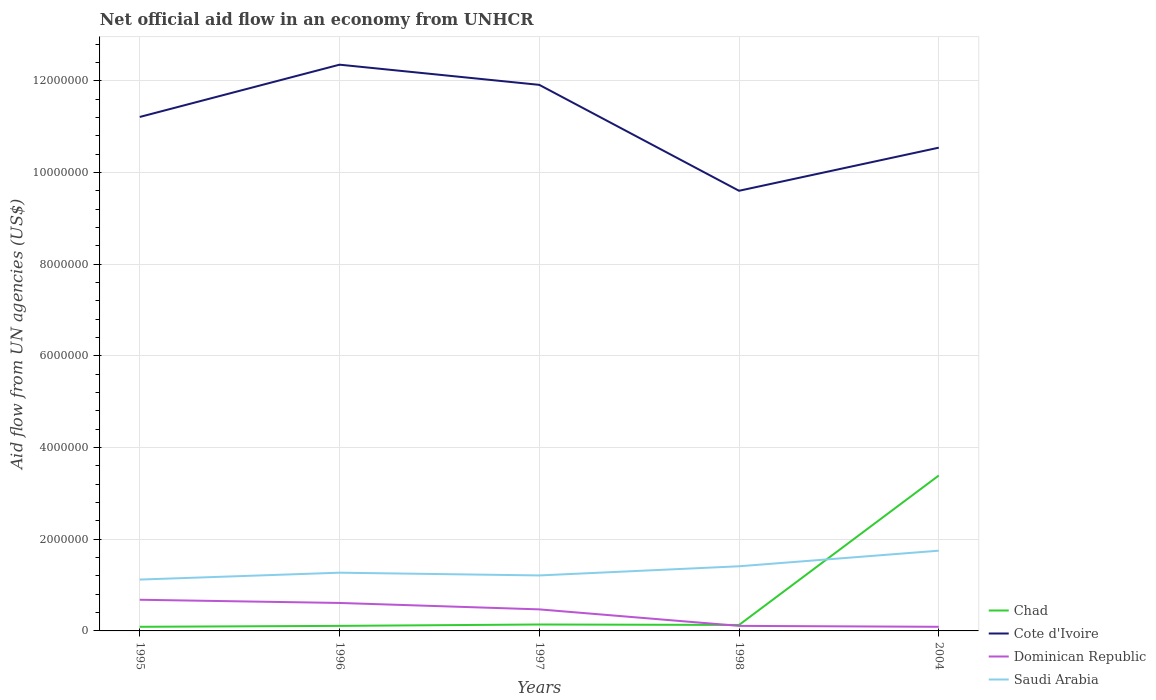Across all years, what is the maximum net official aid flow in Saudi Arabia?
Your answer should be compact. 1.12e+06. In which year was the net official aid flow in Saudi Arabia maximum?
Give a very brief answer. 1995. What is the total net official aid flow in Cote d'Ivoire in the graph?
Offer a terse response. 2.31e+06. What is the difference between the highest and the second highest net official aid flow in Dominican Republic?
Make the answer very short. 5.90e+05. What is the difference between the highest and the lowest net official aid flow in Dominican Republic?
Your response must be concise. 3. How many lines are there?
Make the answer very short. 4. How many years are there in the graph?
Your answer should be very brief. 5. Does the graph contain any zero values?
Your answer should be compact. No. Does the graph contain grids?
Keep it short and to the point. Yes. How many legend labels are there?
Your answer should be very brief. 4. How are the legend labels stacked?
Provide a short and direct response. Vertical. What is the title of the graph?
Provide a succinct answer. Net official aid flow in an economy from UNHCR. What is the label or title of the Y-axis?
Your response must be concise. Aid flow from UN agencies (US$). What is the Aid flow from UN agencies (US$) in Chad in 1995?
Your answer should be very brief. 9.00e+04. What is the Aid flow from UN agencies (US$) of Cote d'Ivoire in 1995?
Offer a terse response. 1.12e+07. What is the Aid flow from UN agencies (US$) in Dominican Republic in 1995?
Ensure brevity in your answer.  6.80e+05. What is the Aid flow from UN agencies (US$) of Saudi Arabia in 1995?
Keep it short and to the point. 1.12e+06. What is the Aid flow from UN agencies (US$) in Chad in 1996?
Your response must be concise. 1.10e+05. What is the Aid flow from UN agencies (US$) in Cote d'Ivoire in 1996?
Ensure brevity in your answer.  1.24e+07. What is the Aid flow from UN agencies (US$) in Saudi Arabia in 1996?
Provide a succinct answer. 1.27e+06. What is the Aid flow from UN agencies (US$) in Cote d'Ivoire in 1997?
Your answer should be very brief. 1.19e+07. What is the Aid flow from UN agencies (US$) in Saudi Arabia in 1997?
Make the answer very short. 1.21e+06. What is the Aid flow from UN agencies (US$) of Chad in 1998?
Your answer should be very brief. 1.30e+05. What is the Aid flow from UN agencies (US$) of Cote d'Ivoire in 1998?
Your response must be concise. 9.60e+06. What is the Aid flow from UN agencies (US$) of Dominican Republic in 1998?
Your answer should be very brief. 1.10e+05. What is the Aid flow from UN agencies (US$) in Saudi Arabia in 1998?
Your answer should be compact. 1.41e+06. What is the Aid flow from UN agencies (US$) of Chad in 2004?
Your response must be concise. 3.39e+06. What is the Aid flow from UN agencies (US$) in Cote d'Ivoire in 2004?
Your response must be concise. 1.05e+07. What is the Aid flow from UN agencies (US$) in Dominican Republic in 2004?
Ensure brevity in your answer.  9.00e+04. What is the Aid flow from UN agencies (US$) of Saudi Arabia in 2004?
Offer a very short reply. 1.75e+06. Across all years, what is the maximum Aid flow from UN agencies (US$) in Chad?
Provide a short and direct response. 3.39e+06. Across all years, what is the maximum Aid flow from UN agencies (US$) of Cote d'Ivoire?
Provide a succinct answer. 1.24e+07. Across all years, what is the maximum Aid flow from UN agencies (US$) of Dominican Republic?
Provide a short and direct response. 6.80e+05. Across all years, what is the maximum Aid flow from UN agencies (US$) of Saudi Arabia?
Provide a short and direct response. 1.75e+06. Across all years, what is the minimum Aid flow from UN agencies (US$) of Chad?
Your answer should be very brief. 9.00e+04. Across all years, what is the minimum Aid flow from UN agencies (US$) of Cote d'Ivoire?
Your response must be concise. 9.60e+06. Across all years, what is the minimum Aid flow from UN agencies (US$) in Saudi Arabia?
Provide a short and direct response. 1.12e+06. What is the total Aid flow from UN agencies (US$) in Chad in the graph?
Your response must be concise. 3.86e+06. What is the total Aid flow from UN agencies (US$) in Cote d'Ivoire in the graph?
Give a very brief answer. 5.56e+07. What is the total Aid flow from UN agencies (US$) in Dominican Republic in the graph?
Your answer should be compact. 1.96e+06. What is the total Aid flow from UN agencies (US$) in Saudi Arabia in the graph?
Your answer should be compact. 6.76e+06. What is the difference between the Aid flow from UN agencies (US$) of Chad in 1995 and that in 1996?
Your answer should be compact. -2.00e+04. What is the difference between the Aid flow from UN agencies (US$) in Cote d'Ivoire in 1995 and that in 1996?
Offer a very short reply. -1.14e+06. What is the difference between the Aid flow from UN agencies (US$) in Cote d'Ivoire in 1995 and that in 1997?
Provide a short and direct response. -7.00e+05. What is the difference between the Aid flow from UN agencies (US$) of Dominican Republic in 1995 and that in 1997?
Offer a terse response. 2.10e+05. What is the difference between the Aid flow from UN agencies (US$) in Cote d'Ivoire in 1995 and that in 1998?
Offer a terse response. 1.61e+06. What is the difference between the Aid flow from UN agencies (US$) in Dominican Republic in 1995 and that in 1998?
Provide a succinct answer. 5.70e+05. What is the difference between the Aid flow from UN agencies (US$) in Chad in 1995 and that in 2004?
Your response must be concise. -3.30e+06. What is the difference between the Aid flow from UN agencies (US$) of Cote d'Ivoire in 1995 and that in 2004?
Ensure brevity in your answer.  6.70e+05. What is the difference between the Aid flow from UN agencies (US$) in Dominican Republic in 1995 and that in 2004?
Offer a terse response. 5.90e+05. What is the difference between the Aid flow from UN agencies (US$) of Saudi Arabia in 1995 and that in 2004?
Offer a very short reply. -6.30e+05. What is the difference between the Aid flow from UN agencies (US$) of Chad in 1996 and that in 1997?
Make the answer very short. -3.00e+04. What is the difference between the Aid flow from UN agencies (US$) in Cote d'Ivoire in 1996 and that in 1997?
Ensure brevity in your answer.  4.40e+05. What is the difference between the Aid flow from UN agencies (US$) of Cote d'Ivoire in 1996 and that in 1998?
Provide a succinct answer. 2.75e+06. What is the difference between the Aid flow from UN agencies (US$) in Chad in 1996 and that in 2004?
Give a very brief answer. -3.28e+06. What is the difference between the Aid flow from UN agencies (US$) in Cote d'Ivoire in 1996 and that in 2004?
Your answer should be very brief. 1.81e+06. What is the difference between the Aid flow from UN agencies (US$) in Dominican Republic in 1996 and that in 2004?
Your answer should be very brief. 5.20e+05. What is the difference between the Aid flow from UN agencies (US$) in Saudi Arabia in 1996 and that in 2004?
Ensure brevity in your answer.  -4.80e+05. What is the difference between the Aid flow from UN agencies (US$) in Cote d'Ivoire in 1997 and that in 1998?
Provide a succinct answer. 2.31e+06. What is the difference between the Aid flow from UN agencies (US$) in Dominican Republic in 1997 and that in 1998?
Keep it short and to the point. 3.60e+05. What is the difference between the Aid flow from UN agencies (US$) of Saudi Arabia in 1997 and that in 1998?
Make the answer very short. -2.00e+05. What is the difference between the Aid flow from UN agencies (US$) of Chad in 1997 and that in 2004?
Provide a short and direct response. -3.25e+06. What is the difference between the Aid flow from UN agencies (US$) of Cote d'Ivoire in 1997 and that in 2004?
Your answer should be compact. 1.37e+06. What is the difference between the Aid flow from UN agencies (US$) in Dominican Republic in 1997 and that in 2004?
Your answer should be compact. 3.80e+05. What is the difference between the Aid flow from UN agencies (US$) in Saudi Arabia in 1997 and that in 2004?
Give a very brief answer. -5.40e+05. What is the difference between the Aid flow from UN agencies (US$) in Chad in 1998 and that in 2004?
Make the answer very short. -3.26e+06. What is the difference between the Aid flow from UN agencies (US$) in Cote d'Ivoire in 1998 and that in 2004?
Offer a very short reply. -9.40e+05. What is the difference between the Aid flow from UN agencies (US$) of Dominican Republic in 1998 and that in 2004?
Ensure brevity in your answer.  2.00e+04. What is the difference between the Aid flow from UN agencies (US$) of Chad in 1995 and the Aid flow from UN agencies (US$) of Cote d'Ivoire in 1996?
Keep it short and to the point. -1.23e+07. What is the difference between the Aid flow from UN agencies (US$) in Chad in 1995 and the Aid flow from UN agencies (US$) in Dominican Republic in 1996?
Ensure brevity in your answer.  -5.20e+05. What is the difference between the Aid flow from UN agencies (US$) of Chad in 1995 and the Aid flow from UN agencies (US$) of Saudi Arabia in 1996?
Keep it short and to the point. -1.18e+06. What is the difference between the Aid flow from UN agencies (US$) in Cote d'Ivoire in 1995 and the Aid flow from UN agencies (US$) in Dominican Republic in 1996?
Offer a terse response. 1.06e+07. What is the difference between the Aid flow from UN agencies (US$) in Cote d'Ivoire in 1995 and the Aid flow from UN agencies (US$) in Saudi Arabia in 1996?
Offer a terse response. 9.94e+06. What is the difference between the Aid flow from UN agencies (US$) of Dominican Republic in 1995 and the Aid flow from UN agencies (US$) of Saudi Arabia in 1996?
Your response must be concise. -5.90e+05. What is the difference between the Aid flow from UN agencies (US$) of Chad in 1995 and the Aid flow from UN agencies (US$) of Cote d'Ivoire in 1997?
Make the answer very short. -1.18e+07. What is the difference between the Aid flow from UN agencies (US$) of Chad in 1995 and the Aid flow from UN agencies (US$) of Dominican Republic in 1997?
Offer a very short reply. -3.80e+05. What is the difference between the Aid flow from UN agencies (US$) of Chad in 1995 and the Aid flow from UN agencies (US$) of Saudi Arabia in 1997?
Give a very brief answer. -1.12e+06. What is the difference between the Aid flow from UN agencies (US$) of Cote d'Ivoire in 1995 and the Aid flow from UN agencies (US$) of Dominican Republic in 1997?
Your answer should be very brief. 1.07e+07. What is the difference between the Aid flow from UN agencies (US$) of Cote d'Ivoire in 1995 and the Aid flow from UN agencies (US$) of Saudi Arabia in 1997?
Provide a succinct answer. 1.00e+07. What is the difference between the Aid flow from UN agencies (US$) in Dominican Republic in 1995 and the Aid flow from UN agencies (US$) in Saudi Arabia in 1997?
Your response must be concise. -5.30e+05. What is the difference between the Aid flow from UN agencies (US$) of Chad in 1995 and the Aid flow from UN agencies (US$) of Cote d'Ivoire in 1998?
Your response must be concise. -9.51e+06. What is the difference between the Aid flow from UN agencies (US$) in Chad in 1995 and the Aid flow from UN agencies (US$) in Dominican Republic in 1998?
Your answer should be compact. -2.00e+04. What is the difference between the Aid flow from UN agencies (US$) of Chad in 1995 and the Aid flow from UN agencies (US$) of Saudi Arabia in 1998?
Your response must be concise. -1.32e+06. What is the difference between the Aid flow from UN agencies (US$) of Cote d'Ivoire in 1995 and the Aid flow from UN agencies (US$) of Dominican Republic in 1998?
Offer a terse response. 1.11e+07. What is the difference between the Aid flow from UN agencies (US$) in Cote d'Ivoire in 1995 and the Aid flow from UN agencies (US$) in Saudi Arabia in 1998?
Offer a terse response. 9.80e+06. What is the difference between the Aid flow from UN agencies (US$) in Dominican Republic in 1995 and the Aid flow from UN agencies (US$) in Saudi Arabia in 1998?
Keep it short and to the point. -7.30e+05. What is the difference between the Aid flow from UN agencies (US$) of Chad in 1995 and the Aid flow from UN agencies (US$) of Cote d'Ivoire in 2004?
Your response must be concise. -1.04e+07. What is the difference between the Aid flow from UN agencies (US$) in Chad in 1995 and the Aid flow from UN agencies (US$) in Dominican Republic in 2004?
Offer a very short reply. 0. What is the difference between the Aid flow from UN agencies (US$) of Chad in 1995 and the Aid flow from UN agencies (US$) of Saudi Arabia in 2004?
Your answer should be compact. -1.66e+06. What is the difference between the Aid flow from UN agencies (US$) of Cote d'Ivoire in 1995 and the Aid flow from UN agencies (US$) of Dominican Republic in 2004?
Your answer should be very brief. 1.11e+07. What is the difference between the Aid flow from UN agencies (US$) in Cote d'Ivoire in 1995 and the Aid flow from UN agencies (US$) in Saudi Arabia in 2004?
Offer a terse response. 9.46e+06. What is the difference between the Aid flow from UN agencies (US$) in Dominican Republic in 1995 and the Aid flow from UN agencies (US$) in Saudi Arabia in 2004?
Give a very brief answer. -1.07e+06. What is the difference between the Aid flow from UN agencies (US$) of Chad in 1996 and the Aid flow from UN agencies (US$) of Cote d'Ivoire in 1997?
Keep it short and to the point. -1.18e+07. What is the difference between the Aid flow from UN agencies (US$) of Chad in 1996 and the Aid flow from UN agencies (US$) of Dominican Republic in 1997?
Keep it short and to the point. -3.60e+05. What is the difference between the Aid flow from UN agencies (US$) in Chad in 1996 and the Aid flow from UN agencies (US$) in Saudi Arabia in 1997?
Make the answer very short. -1.10e+06. What is the difference between the Aid flow from UN agencies (US$) in Cote d'Ivoire in 1996 and the Aid flow from UN agencies (US$) in Dominican Republic in 1997?
Your answer should be compact. 1.19e+07. What is the difference between the Aid flow from UN agencies (US$) in Cote d'Ivoire in 1996 and the Aid flow from UN agencies (US$) in Saudi Arabia in 1997?
Provide a short and direct response. 1.11e+07. What is the difference between the Aid flow from UN agencies (US$) in Dominican Republic in 1996 and the Aid flow from UN agencies (US$) in Saudi Arabia in 1997?
Your response must be concise. -6.00e+05. What is the difference between the Aid flow from UN agencies (US$) in Chad in 1996 and the Aid flow from UN agencies (US$) in Cote d'Ivoire in 1998?
Give a very brief answer. -9.49e+06. What is the difference between the Aid flow from UN agencies (US$) of Chad in 1996 and the Aid flow from UN agencies (US$) of Saudi Arabia in 1998?
Your answer should be very brief. -1.30e+06. What is the difference between the Aid flow from UN agencies (US$) in Cote d'Ivoire in 1996 and the Aid flow from UN agencies (US$) in Dominican Republic in 1998?
Offer a terse response. 1.22e+07. What is the difference between the Aid flow from UN agencies (US$) of Cote d'Ivoire in 1996 and the Aid flow from UN agencies (US$) of Saudi Arabia in 1998?
Provide a succinct answer. 1.09e+07. What is the difference between the Aid flow from UN agencies (US$) of Dominican Republic in 1996 and the Aid flow from UN agencies (US$) of Saudi Arabia in 1998?
Your response must be concise. -8.00e+05. What is the difference between the Aid flow from UN agencies (US$) of Chad in 1996 and the Aid flow from UN agencies (US$) of Cote d'Ivoire in 2004?
Your answer should be very brief. -1.04e+07. What is the difference between the Aid flow from UN agencies (US$) of Chad in 1996 and the Aid flow from UN agencies (US$) of Dominican Republic in 2004?
Keep it short and to the point. 2.00e+04. What is the difference between the Aid flow from UN agencies (US$) of Chad in 1996 and the Aid flow from UN agencies (US$) of Saudi Arabia in 2004?
Give a very brief answer. -1.64e+06. What is the difference between the Aid flow from UN agencies (US$) of Cote d'Ivoire in 1996 and the Aid flow from UN agencies (US$) of Dominican Republic in 2004?
Your answer should be compact. 1.23e+07. What is the difference between the Aid flow from UN agencies (US$) of Cote d'Ivoire in 1996 and the Aid flow from UN agencies (US$) of Saudi Arabia in 2004?
Your answer should be compact. 1.06e+07. What is the difference between the Aid flow from UN agencies (US$) of Dominican Republic in 1996 and the Aid flow from UN agencies (US$) of Saudi Arabia in 2004?
Make the answer very short. -1.14e+06. What is the difference between the Aid flow from UN agencies (US$) of Chad in 1997 and the Aid flow from UN agencies (US$) of Cote d'Ivoire in 1998?
Your response must be concise. -9.46e+06. What is the difference between the Aid flow from UN agencies (US$) of Chad in 1997 and the Aid flow from UN agencies (US$) of Saudi Arabia in 1998?
Ensure brevity in your answer.  -1.27e+06. What is the difference between the Aid flow from UN agencies (US$) of Cote d'Ivoire in 1997 and the Aid flow from UN agencies (US$) of Dominican Republic in 1998?
Your answer should be compact. 1.18e+07. What is the difference between the Aid flow from UN agencies (US$) in Cote d'Ivoire in 1997 and the Aid flow from UN agencies (US$) in Saudi Arabia in 1998?
Keep it short and to the point. 1.05e+07. What is the difference between the Aid flow from UN agencies (US$) in Dominican Republic in 1997 and the Aid flow from UN agencies (US$) in Saudi Arabia in 1998?
Give a very brief answer. -9.40e+05. What is the difference between the Aid flow from UN agencies (US$) in Chad in 1997 and the Aid flow from UN agencies (US$) in Cote d'Ivoire in 2004?
Your answer should be very brief. -1.04e+07. What is the difference between the Aid flow from UN agencies (US$) in Chad in 1997 and the Aid flow from UN agencies (US$) in Dominican Republic in 2004?
Make the answer very short. 5.00e+04. What is the difference between the Aid flow from UN agencies (US$) in Chad in 1997 and the Aid flow from UN agencies (US$) in Saudi Arabia in 2004?
Offer a very short reply. -1.61e+06. What is the difference between the Aid flow from UN agencies (US$) of Cote d'Ivoire in 1997 and the Aid flow from UN agencies (US$) of Dominican Republic in 2004?
Offer a very short reply. 1.18e+07. What is the difference between the Aid flow from UN agencies (US$) in Cote d'Ivoire in 1997 and the Aid flow from UN agencies (US$) in Saudi Arabia in 2004?
Give a very brief answer. 1.02e+07. What is the difference between the Aid flow from UN agencies (US$) in Dominican Republic in 1997 and the Aid flow from UN agencies (US$) in Saudi Arabia in 2004?
Your response must be concise. -1.28e+06. What is the difference between the Aid flow from UN agencies (US$) in Chad in 1998 and the Aid flow from UN agencies (US$) in Cote d'Ivoire in 2004?
Your answer should be compact. -1.04e+07. What is the difference between the Aid flow from UN agencies (US$) in Chad in 1998 and the Aid flow from UN agencies (US$) in Dominican Republic in 2004?
Your response must be concise. 4.00e+04. What is the difference between the Aid flow from UN agencies (US$) in Chad in 1998 and the Aid flow from UN agencies (US$) in Saudi Arabia in 2004?
Provide a succinct answer. -1.62e+06. What is the difference between the Aid flow from UN agencies (US$) of Cote d'Ivoire in 1998 and the Aid flow from UN agencies (US$) of Dominican Republic in 2004?
Provide a short and direct response. 9.51e+06. What is the difference between the Aid flow from UN agencies (US$) in Cote d'Ivoire in 1998 and the Aid flow from UN agencies (US$) in Saudi Arabia in 2004?
Your answer should be compact. 7.85e+06. What is the difference between the Aid flow from UN agencies (US$) in Dominican Republic in 1998 and the Aid flow from UN agencies (US$) in Saudi Arabia in 2004?
Offer a terse response. -1.64e+06. What is the average Aid flow from UN agencies (US$) in Chad per year?
Provide a short and direct response. 7.72e+05. What is the average Aid flow from UN agencies (US$) in Cote d'Ivoire per year?
Offer a very short reply. 1.11e+07. What is the average Aid flow from UN agencies (US$) of Dominican Republic per year?
Your response must be concise. 3.92e+05. What is the average Aid flow from UN agencies (US$) of Saudi Arabia per year?
Make the answer very short. 1.35e+06. In the year 1995, what is the difference between the Aid flow from UN agencies (US$) in Chad and Aid flow from UN agencies (US$) in Cote d'Ivoire?
Ensure brevity in your answer.  -1.11e+07. In the year 1995, what is the difference between the Aid flow from UN agencies (US$) of Chad and Aid flow from UN agencies (US$) of Dominican Republic?
Offer a very short reply. -5.90e+05. In the year 1995, what is the difference between the Aid flow from UN agencies (US$) in Chad and Aid flow from UN agencies (US$) in Saudi Arabia?
Offer a terse response. -1.03e+06. In the year 1995, what is the difference between the Aid flow from UN agencies (US$) in Cote d'Ivoire and Aid flow from UN agencies (US$) in Dominican Republic?
Your answer should be compact. 1.05e+07. In the year 1995, what is the difference between the Aid flow from UN agencies (US$) in Cote d'Ivoire and Aid flow from UN agencies (US$) in Saudi Arabia?
Your response must be concise. 1.01e+07. In the year 1995, what is the difference between the Aid flow from UN agencies (US$) of Dominican Republic and Aid flow from UN agencies (US$) of Saudi Arabia?
Your response must be concise. -4.40e+05. In the year 1996, what is the difference between the Aid flow from UN agencies (US$) in Chad and Aid flow from UN agencies (US$) in Cote d'Ivoire?
Keep it short and to the point. -1.22e+07. In the year 1996, what is the difference between the Aid flow from UN agencies (US$) of Chad and Aid flow from UN agencies (US$) of Dominican Republic?
Your response must be concise. -5.00e+05. In the year 1996, what is the difference between the Aid flow from UN agencies (US$) in Chad and Aid flow from UN agencies (US$) in Saudi Arabia?
Offer a very short reply. -1.16e+06. In the year 1996, what is the difference between the Aid flow from UN agencies (US$) of Cote d'Ivoire and Aid flow from UN agencies (US$) of Dominican Republic?
Provide a succinct answer. 1.17e+07. In the year 1996, what is the difference between the Aid flow from UN agencies (US$) in Cote d'Ivoire and Aid flow from UN agencies (US$) in Saudi Arabia?
Ensure brevity in your answer.  1.11e+07. In the year 1996, what is the difference between the Aid flow from UN agencies (US$) in Dominican Republic and Aid flow from UN agencies (US$) in Saudi Arabia?
Your response must be concise. -6.60e+05. In the year 1997, what is the difference between the Aid flow from UN agencies (US$) in Chad and Aid flow from UN agencies (US$) in Cote d'Ivoire?
Your answer should be compact. -1.18e+07. In the year 1997, what is the difference between the Aid flow from UN agencies (US$) in Chad and Aid flow from UN agencies (US$) in Dominican Republic?
Keep it short and to the point. -3.30e+05. In the year 1997, what is the difference between the Aid flow from UN agencies (US$) of Chad and Aid flow from UN agencies (US$) of Saudi Arabia?
Keep it short and to the point. -1.07e+06. In the year 1997, what is the difference between the Aid flow from UN agencies (US$) in Cote d'Ivoire and Aid flow from UN agencies (US$) in Dominican Republic?
Keep it short and to the point. 1.14e+07. In the year 1997, what is the difference between the Aid flow from UN agencies (US$) of Cote d'Ivoire and Aid flow from UN agencies (US$) of Saudi Arabia?
Your response must be concise. 1.07e+07. In the year 1997, what is the difference between the Aid flow from UN agencies (US$) of Dominican Republic and Aid flow from UN agencies (US$) of Saudi Arabia?
Provide a short and direct response. -7.40e+05. In the year 1998, what is the difference between the Aid flow from UN agencies (US$) of Chad and Aid flow from UN agencies (US$) of Cote d'Ivoire?
Ensure brevity in your answer.  -9.47e+06. In the year 1998, what is the difference between the Aid flow from UN agencies (US$) in Chad and Aid flow from UN agencies (US$) in Dominican Republic?
Your answer should be compact. 2.00e+04. In the year 1998, what is the difference between the Aid flow from UN agencies (US$) of Chad and Aid flow from UN agencies (US$) of Saudi Arabia?
Provide a succinct answer. -1.28e+06. In the year 1998, what is the difference between the Aid flow from UN agencies (US$) in Cote d'Ivoire and Aid flow from UN agencies (US$) in Dominican Republic?
Your answer should be very brief. 9.49e+06. In the year 1998, what is the difference between the Aid flow from UN agencies (US$) in Cote d'Ivoire and Aid flow from UN agencies (US$) in Saudi Arabia?
Your response must be concise. 8.19e+06. In the year 1998, what is the difference between the Aid flow from UN agencies (US$) of Dominican Republic and Aid flow from UN agencies (US$) of Saudi Arabia?
Your answer should be very brief. -1.30e+06. In the year 2004, what is the difference between the Aid flow from UN agencies (US$) of Chad and Aid flow from UN agencies (US$) of Cote d'Ivoire?
Your response must be concise. -7.15e+06. In the year 2004, what is the difference between the Aid flow from UN agencies (US$) of Chad and Aid flow from UN agencies (US$) of Dominican Republic?
Make the answer very short. 3.30e+06. In the year 2004, what is the difference between the Aid flow from UN agencies (US$) in Chad and Aid flow from UN agencies (US$) in Saudi Arabia?
Ensure brevity in your answer.  1.64e+06. In the year 2004, what is the difference between the Aid flow from UN agencies (US$) in Cote d'Ivoire and Aid flow from UN agencies (US$) in Dominican Republic?
Your answer should be very brief. 1.04e+07. In the year 2004, what is the difference between the Aid flow from UN agencies (US$) of Cote d'Ivoire and Aid flow from UN agencies (US$) of Saudi Arabia?
Your answer should be compact. 8.79e+06. In the year 2004, what is the difference between the Aid flow from UN agencies (US$) in Dominican Republic and Aid flow from UN agencies (US$) in Saudi Arabia?
Provide a succinct answer. -1.66e+06. What is the ratio of the Aid flow from UN agencies (US$) of Chad in 1995 to that in 1996?
Provide a short and direct response. 0.82. What is the ratio of the Aid flow from UN agencies (US$) in Cote d'Ivoire in 1995 to that in 1996?
Your answer should be compact. 0.91. What is the ratio of the Aid flow from UN agencies (US$) in Dominican Republic in 1995 to that in 1996?
Provide a succinct answer. 1.11. What is the ratio of the Aid flow from UN agencies (US$) of Saudi Arabia in 1995 to that in 1996?
Your answer should be very brief. 0.88. What is the ratio of the Aid flow from UN agencies (US$) of Chad in 1995 to that in 1997?
Your answer should be compact. 0.64. What is the ratio of the Aid flow from UN agencies (US$) in Dominican Republic in 1995 to that in 1997?
Make the answer very short. 1.45. What is the ratio of the Aid flow from UN agencies (US$) of Saudi Arabia in 1995 to that in 1997?
Your response must be concise. 0.93. What is the ratio of the Aid flow from UN agencies (US$) in Chad in 1995 to that in 1998?
Provide a succinct answer. 0.69. What is the ratio of the Aid flow from UN agencies (US$) in Cote d'Ivoire in 1995 to that in 1998?
Your answer should be very brief. 1.17. What is the ratio of the Aid flow from UN agencies (US$) of Dominican Republic in 1995 to that in 1998?
Make the answer very short. 6.18. What is the ratio of the Aid flow from UN agencies (US$) of Saudi Arabia in 1995 to that in 1998?
Your answer should be compact. 0.79. What is the ratio of the Aid flow from UN agencies (US$) of Chad in 1995 to that in 2004?
Provide a succinct answer. 0.03. What is the ratio of the Aid flow from UN agencies (US$) in Cote d'Ivoire in 1995 to that in 2004?
Offer a terse response. 1.06. What is the ratio of the Aid flow from UN agencies (US$) in Dominican Republic in 1995 to that in 2004?
Your answer should be very brief. 7.56. What is the ratio of the Aid flow from UN agencies (US$) in Saudi Arabia in 1995 to that in 2004?
Provide a short and direct response. 0.64. What is the ratio of the Aid flow from UN agencies (US$) in Chad in 1996 to that in 1997?
Your answer should be very brief. 0.79. What is the ratio of the Aid flow from UN agencies (US$) in Cote d'Ivoire in 1996 to that in 1997?
Make the answer very short. 1.04. What is the ratio of the Aid flow from UN agencies (US$) of Dominican Republic in 1996 to that in 1997?
Your answer should be compact. 1.3. What is the ratio of the Aid flow from UN agencies (US$) in Saudi Arabia in 1996 to that in 1997?
Offer a very short reply. 1.05. What is the ratio of the Aid flow from UN agencies (US$) of Chad in 1996 to that in 1998?
Ensure brevity in your answer.  0.85. What is the ratio of the Aid flow from UN agencies (US$) of Cote d'Ivoire in 1996 to that in 1998?
Provide a succinct answer. 1.29. What is the ratio of the Aid flow from UN agencies (US$) of Dominican Republic in 1996 to that in 1998?
Ensure brevity in your answer.  5.55. What is the ratio of the Aid flow from UN agencies (US$) in Saudi Arabia in 1996 to that in 1998?
Give a very brief answer. 0.9. What is the ratio of the Aid flow from UN agencies (US$) of Chad in 1996 to that in 2004?
Provide a short and direct response. 0.03. What is the ratio of the Aid flow from UN agencies (US$) of Cote d'Ivoire in 1996 to that in 2004?
Offer a terse response. 1.17. What is the ratio of the Aid flow from UN agencies (US$) in Dominican Republic in 1996 to that in 2004?
Provide a succinct answer. 6.78. What is the ratio of the Aid flow from UN agencies (US$) in Saudi Arabia in 1996 to that in 2004?
Ensure brevity in your answer.  0.73. What is the ratio of the Aid flow from UN agencies (US$) of Cote d'Ivoire in 1997 to that in 1998?
Your answer should be compact. 1.24. What is the ratio of the Aid flow from UN agencies (US$) in Dominican Republic in 1997 to that in 1998?
Make the answer very short. 4.27. What is the ratio of the Aid flow from UN agencies (US$) of Saudi Arabia in 1997 to that in 1998?
Your response must be concise. 0.86. What is the ratio of the Aid flow from UN agencies (US$) of Chad in 1997 to that in 2004?
Make the answer very short. 0.04. What is the ratio of the Aid flow from UN agencies (US$) of Cote d'Ivoire in 1997 to that in 2004?
Your response must be concise. 1.13. What is the ratio of the Aid flow from UN agencies (US$) in Dominican Republic in 1997 to that in 2004?
Provide a succinct answer. 5.22. What is the ratio of the Aid flow from UN agencies (US$) of Saudi Arabia in 1997 to that in 2004?
Provide a succinct answer. 0.69. What is the ratio of the Aid flow from UN agencies (US$) of Chad in 1998 to that in 2004?
Provide a succinct answer. 0.04. What is the ratio of the Aid flow from UN agencies (US$) in Cote d'Ivoire in 1998 to that in 2004?
Make the answer very short. 0.91. What is the ratio of the Aid flow from UN agencies (US$) of Dominican Republic in 1998 to that in 2004?
Provide a short and direct response. 1.22. What is the ratio of the Aid flow from UN agencies (US$) of Saudi Arabia in 1998 to that in 2004?
Your answer should be very brief. 0.81. What is the difference between the highest and the second highest Aid flow from UN agencies (US$) in Chad?
Make the answer very short. 3.25e+06. What is the difference between the highest and the second highest Aid flow from UN agencies (US$) in Saudi Arabia?
Keep it short and to the point. 3.40e+05. What is the difference between the highest and the lowest Aid flow from UN agencies (US$) of Chad?
Your answer should be very brief. 3.30e+06. What is the difference between the highest and the lowest Aid flow from UN agencies (US$) in Cote d'Ivoire?
Ensure brevity in your answer.  2.75e+06. What is the difference between the highest and the lowest Aid flow from UN agencies (US$) of Dominican Republic?
Your answer should be compact. 5.90e+05. What is the difference between the highest and the lowest Aid flow from UN agencies (US$) in Saudi Arabia?
Your response must be concise. 6.30e+05. 